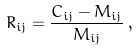Convert formula to latex. <formula><loc_0><loc_0><loc_500><loc_500>R _ { i j } = \frac { C _ { i j } - M _ { i j } } { M _ { i j } } \, ,</formula> 